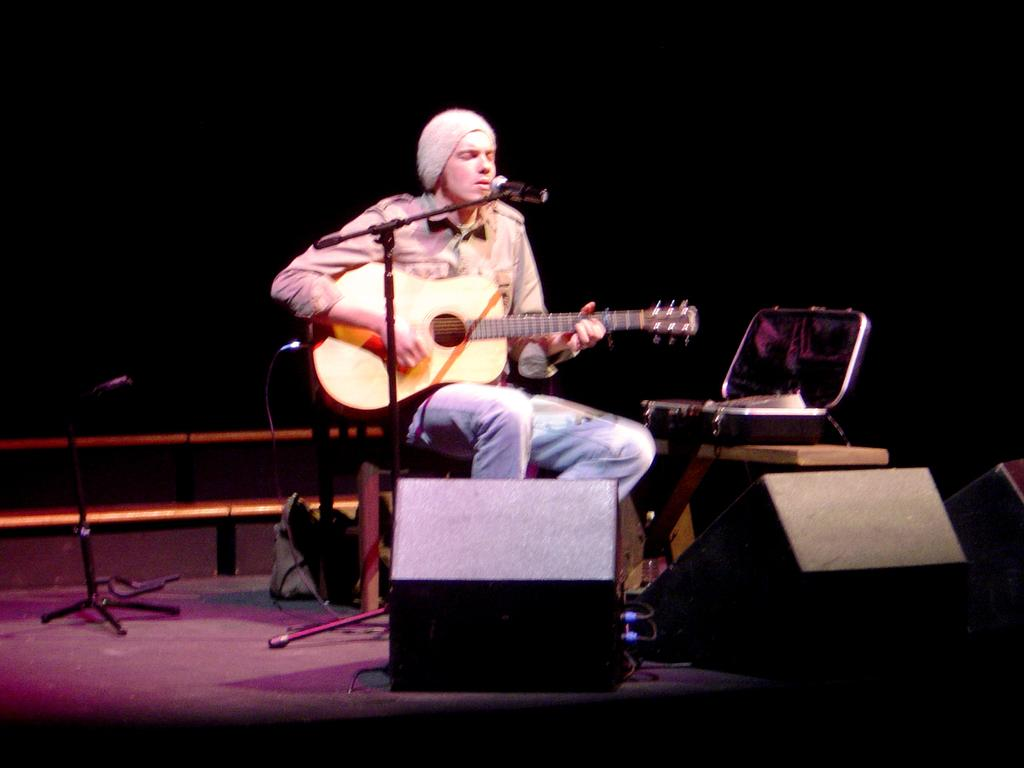Who is the main subject in the image? There is a person in the image. Where is the person located? The person is sitting on a stage. What is the person doing on the stage? The person is playing a guitar and singing. What type of stocking is the person wearing on their head in the image? There is no stocking present on the person's head in the image. 